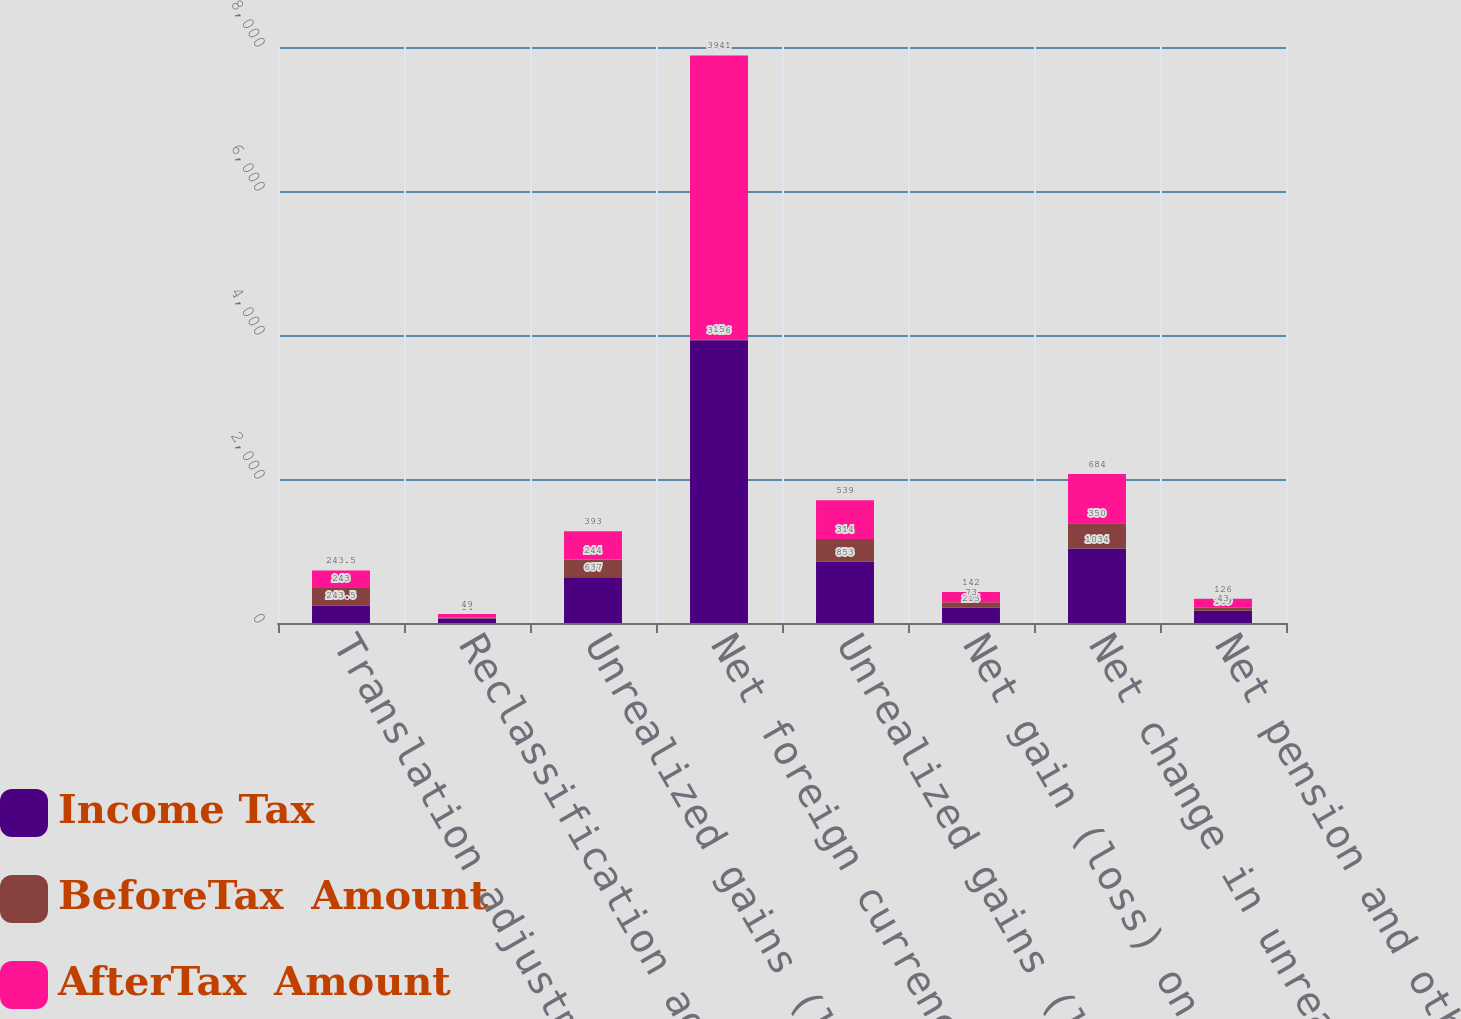Convert chart to OTSL. <chart><loc_0><loc_0><loc_500><loc_500><stacked_bar_chart><ecel><fcel>Translation adjustments<fcel>Reclassification adjustments<fcel>Unrealized gains (losses) on<fcel>Net foreign currency<fcel>Unrealized gains (losses)<fcel>Net gain (loss) on derivatives<fcel>Net change in unrealized gain<fcel>Net pension and other benefits<nl><fcel>Income Tax<fcel>243.5<fcel>63<fcel>637<fcel>3926<fcel>853<fcel>215<fcel>1034<fcel>169<nl><fcel>BeforeTax  Amount<fcel>243<fcel>14<fcel>244<fcel>15<fcel>314<fcel>73<fcel>350<fcel>43<nl><fcel>AfterTax  Amount<fcel>243.5<fcel>49<fcel>393<fcel>3941<fcel>539<fcel>142<fcel>684<fcel>126<nl></chart> 